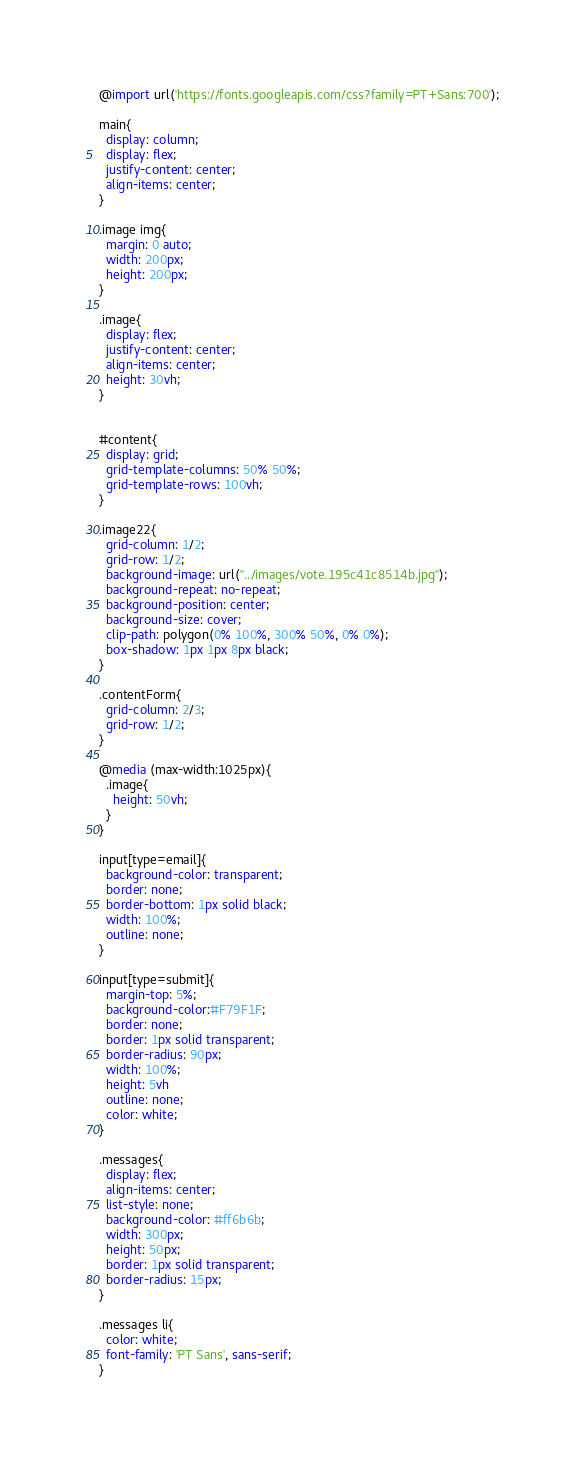<code> <loc_0><loc_0><loc_500><loc_500><_CSS_>@import url('https://fonts.googleapis.com/css?family=PT+Sans:700');

main{
  display: column;
  display: flex;
  justify-content: center;
  align-items: center;
}

.image img{
  margin: 0 auto;
  width: 200px;
  height: 200px;
}

.image{
  display: flex;
  justify-content: center;
  align-items: center;
  height: 30vh;
}


#content{
  display: grid;
  grid-template-columns: 50% 50%;
  grid-template-rows: 100vh;
}

.image22{
  grid-column: 1/2;
  grid-row: 1/2;
  background-image: url("../images/vote.195c41c8514b.jpg");
  background-repeat: no-repeat;
  background-position: center;
  background-size: cover;
  clip-path: polygon(0% 100%, 300% 50%, 0% 0%);
  box-shadow: 1px 1px 8px black;
}

.contentForm{
  grid-column: 2/3;
  grid-row: 1/2;
}

@media (max-width:1025px){
  .image{
    height: 50vh;
  }
}

input[type=email]{
  background-color: transparent;
  border: none;
  border-bottom: 1px solid black;
  width: 100%;
  outline: none;
}

input[type=submit]{
  margin-top: 5%;
  background-color:#F79F1F;
  border: none;
  border: 1px solid transparent;
  border-radius: 90px;
  width: 100%;
  height: 5vh
  outline: none;
  color: white;
}

.messages{
  display: flex;
  align-items: center;
  list-style: none;
  background-color: #ff6b6b;
  width: 300px;
  height: 50px;
  border: 1px solid transparent;
  border-radius: 15px;
}

.messages li{
  color: white;
  font-family: 'PT Sans', sans-serif;
}
</code> 